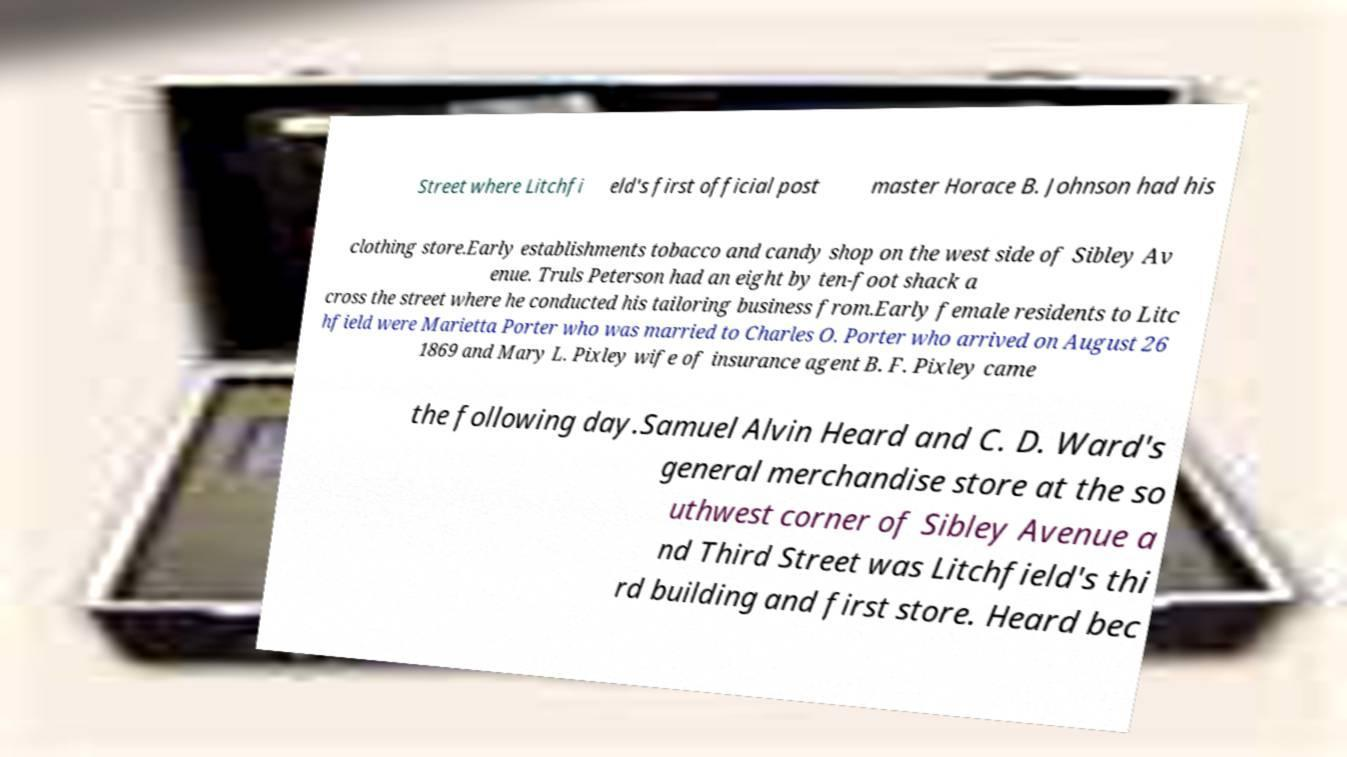Can you read and provide the text displayed in the image?This photo seems to have some interesting text. Can you extract and type it out for me? Street where Litchfi eld's first official post master Horace B. Johnson had his clothing store.Early establishments tobacco and candy shop on the west side of Sibley Av enue. Truls Peterson had an eight by ten-foot shack a cross the street where he conducted his tailoring business from.Early female residents to Litc hfield were Marietta Porter who was married to Charles O. Porter who arrived on August 26 1869 and Mary L. Pixley wife of insurance agent B. F. Pixley came the following day.Samuel Alvin Heard and C. D. Ward's general merchandise store at the so uthwest corner of Sibley Avenue a nd Third Street was Litchfield's thi rd building and first store. Heard bec 